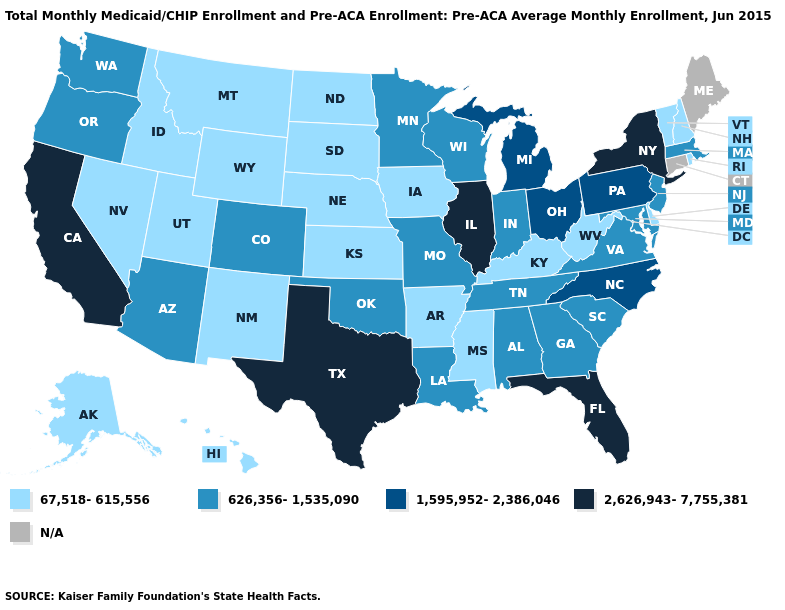Which states have the lowest value in the USA?
Keep it brief. Alaska, Arkansas, Delaware, Hawaii, Idaho, Iowa, Kansas, Kentucky, Mississippi, Montana, Nebraska, Nevada, New Hampshire, New Mexico, North Dakota, Rhode Island, South Dakota, Utah, Vermont, West Virginia, Wyoming. How many symbols are there in the legend?
Keep it brief. 5. Among the states that border South Carolina , which have the highest value?
Quick response, please. North Carolina. Among the states that border Nebraska , does Missouri have the highest value?
Be succinct. Yes. Among the states that border Louisiana , does Texas have the lowest value?
Keep it brief. No. What is the highest value in states that border Virginia?
Give a very brief answer. 1,595,952-2,386,046. Which states have the lowest value in the MidWest?
Give a very brief answer. Iowa, Kansas, Nebraska, North Dakota, South Dakota. Is the legend a continuous bar?
Keep it brief. No. What is the value of California?
Be succinct. 2,626,943-7,755,381. What is the value of New Jersey?
Answer briefly. 626,356-1,535,090. Name the states that have a value in the range 1,595,952-2,386,046?
Quick response, please. Michigan, North Carolina, Ohio, Pennsylvania. Which states have the lowest value in the USA?
Answer briefly. Alaska, Arkansas, Delaware, Hawaii, Idaho, Iowa, Kansas, Kentucky, Mississippi, Montana, Nebraska, Nevada, New Hampshire, New Mexico, North Dakota, Rhode Island, South Dakota, Utah, Vermont, West Virginia, Wyoming. Does the first symbol in the legend represent the smallest category?
Short answer required. Yes. 